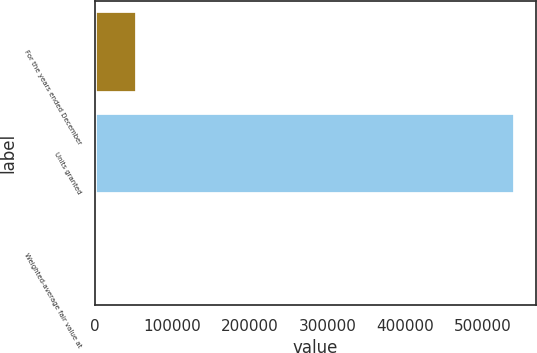Convert chart. <chart><loc_0><loc_0><loc_500><loc_500><bar_chart><fcel>For the years ended December<fcel>Units granted<fcel>Weighted-average fair value at<nl><fcel>54196.3<fcel>541623<fcel>37.78<nl></chart> 